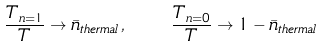<formula> <loc_0><loc_0><loc_500><loc_500>\frac { T _ { n = 1 } } { T } \rightarrow \bar { n } _ { t h e r m a l } \, , \quad \frac { T _ { n = 0 } } { T } \rightarrow 1 - \bar { n } _ { t h e r m a l }</formula> 